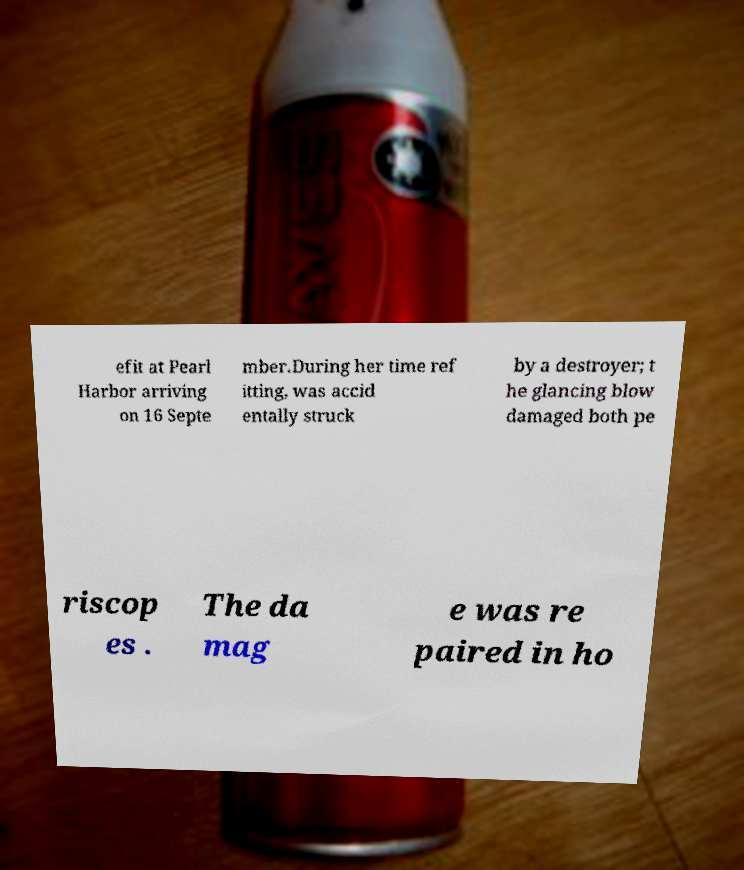Please read and relay the text visible in this image. What does it say? efit at Pearl Harbor arriving on 16 Septe mber.During her time ref itting, was accid entally struck by a destroyer; t he glancing blow damaged both pe riscop es . The da mag e was re paired in ho 